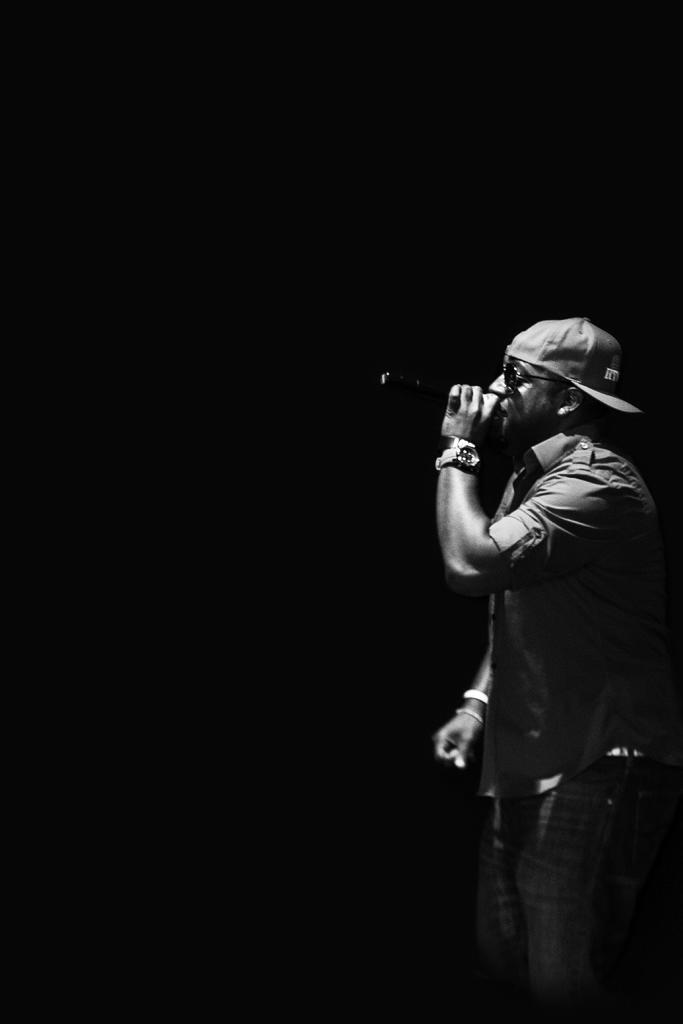What is the color scheme of the image? The image is black and white. How would you describe the background of the image? The background of the image is dark. Can you identify any person in the image? Yes, there is a man in the image. Where is the man positioned in the image? The man is standing on the right side of the image. What is the man doing in the image? The man is singing on a microphone. Can you tell me how many yokes are present in the image? There are no yokes present in the image. What type of weight is the man lifting in the image? The man is not lifting any weights in the image; he is singing on a microphone. 